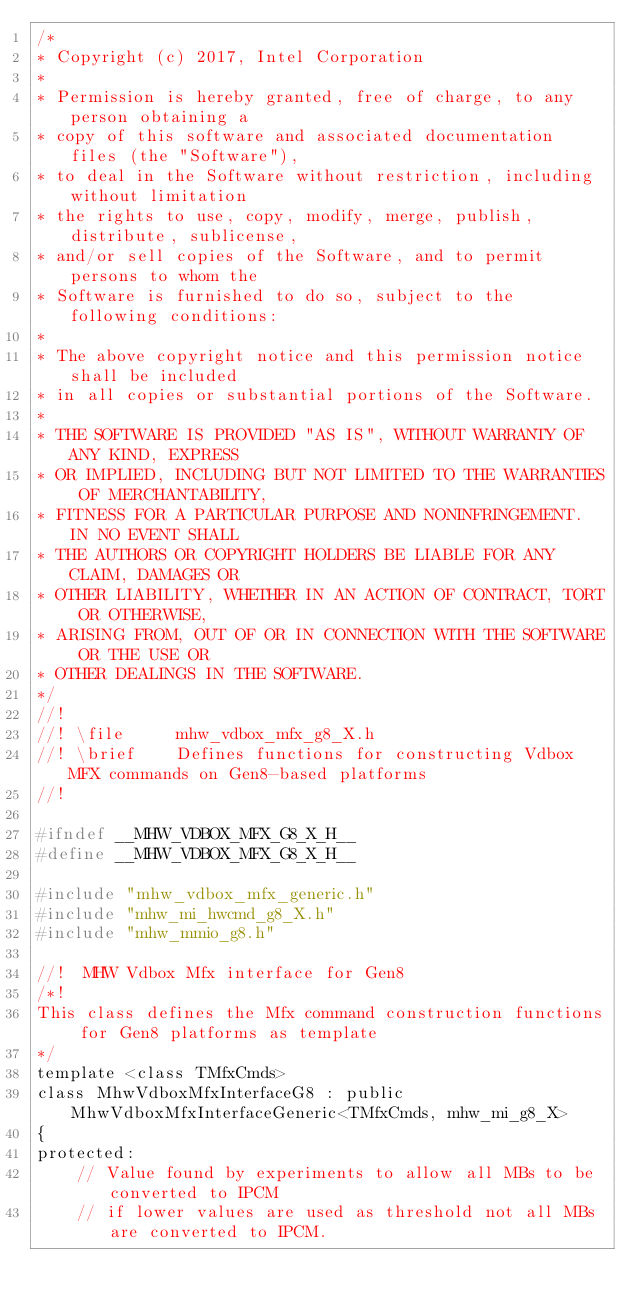<code> <loc_0><loc_0><loc_500><loc_500><_C_>/*
* Copyright (c) 2017, Intel Corporation
*
* Permission is hereby granted, free of charge, to any person obtaining a
* copy of this software and associated documentation files (the "Software"),
* to deal in the Software without restriction, including without limitation
* the rights to use, copy, modify, merge, publish, distribute, sublicense,
* and/or sell copies of the Software, and to permit persons to whom the
* Software is furnished to do so, subject to the following conditions:
*
* The above copyright notice and this permission notice shall be included
* in all copies or substantial portions of the Software.
*
* THE SOFTWARE IS PROVIDED "AS IS", WITHOUT WARRANTY OF ANY KIND, EXPRESS
* OR IMPLIED, INCLUDING BUT NOT LIMITED TO THE WARRANTIES OF MERCHANTABILITY,
* FITNESS FOR A PARTICULAR PURPOSE AND NONINFRINGEMENT. IN NO EVENT SHALL
* THE AUTHORS OR COPYRIGHT HOLDERS BE LIABLE FOR ANY CLAIM, DAMAGES OR
* OTHER LIABILITY, WHETHER IN AN ACTION OF CONTRACT, TORT OR OTHERWISE,
* ARISING FROM, OUT OF OR IN CONNECTION WITH THE SOFTWARE OR THE USE OR
* OTHER DEALINGS IN THE SOFTWARE.
*/
//!
//! \file     mhw_vdbox_mfx_g8_X.h
//! \brief    Defines functions for constructing Vdbox MFX commands on Gen8-based platforms
//!

#ifndef __MHW_VDBOX_MFX_G8_X_H__
#define __MHW_VDBOX_MFX_G8_X_H__

#include "mhw_vdbox_mfx_generic.h"
#include "mhw_mi_hwcmd_g8_X.h"
#include "mhw_mmio_g8.h"

//!  MHW Vdbox Mfx interface for Gen8
/*!
This class defines the Mfx command construction functions for Gen8 platforms as template
*/
template <class TMfxCmds>
class MhwVdboxMfxInterfaceG8 : public MhwVdboxMfxInterfaceGeneric<TMfxCmds, mhw_mi_g8_X>
{
protected:
    // Value found by experiments to allow all MBs to be converted to IPCM
    // if lower values are used as threshold not all MBs are converted to IPCM.</code> 